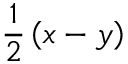<formula> <loc_0><loc_0><loc_500><loc_500>{ \frac { 1 } { 2 } } \left ( x - y \right )</formula> 